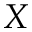<formula> <loc_0><loc_0><loc_500><loc_500>X</formula> 